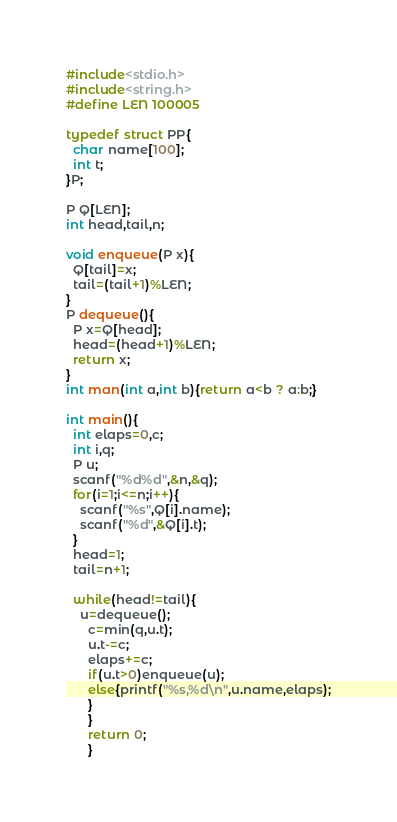<code> <loc_0><loc_0><loc_500><loc_500><_C_>#include<stdio.h>
#include<string.h>
#define LEN 100005

typedef struct PP{
  char name[100];
  int t;
}P;

P Q[LEN];
int head,tail,n;

void enqueue(P x){
  Q[tail]=x;
  tail=(tail+1)%LEN;
}
P dequeue(){
  P x=Q[head];
  head=(head+1)%LEN;
  return x;
}
int man(int a,int b){return a<b ? a:b;}

int main(){
  int elaps=0,c;
  int i,q;
  P u;
  scanf("%d%d",&n,&q);
  for(i=1;i<=n;i++){
    scanf("%s",Q[i].name);
    scanf("%d",&Q[i].t);
  }
  head=1;
  tail=n+1;

  while(head!=tail){
    u=dequeue();
      c=min(q,u.t);
      u.t-=c;
      elaps+=c;
      if(u.t>0)enqueue(u);
      else{printf("%s,%d\n",u.name,elaps);
      }
      }
      return 0;
      }

</code> 